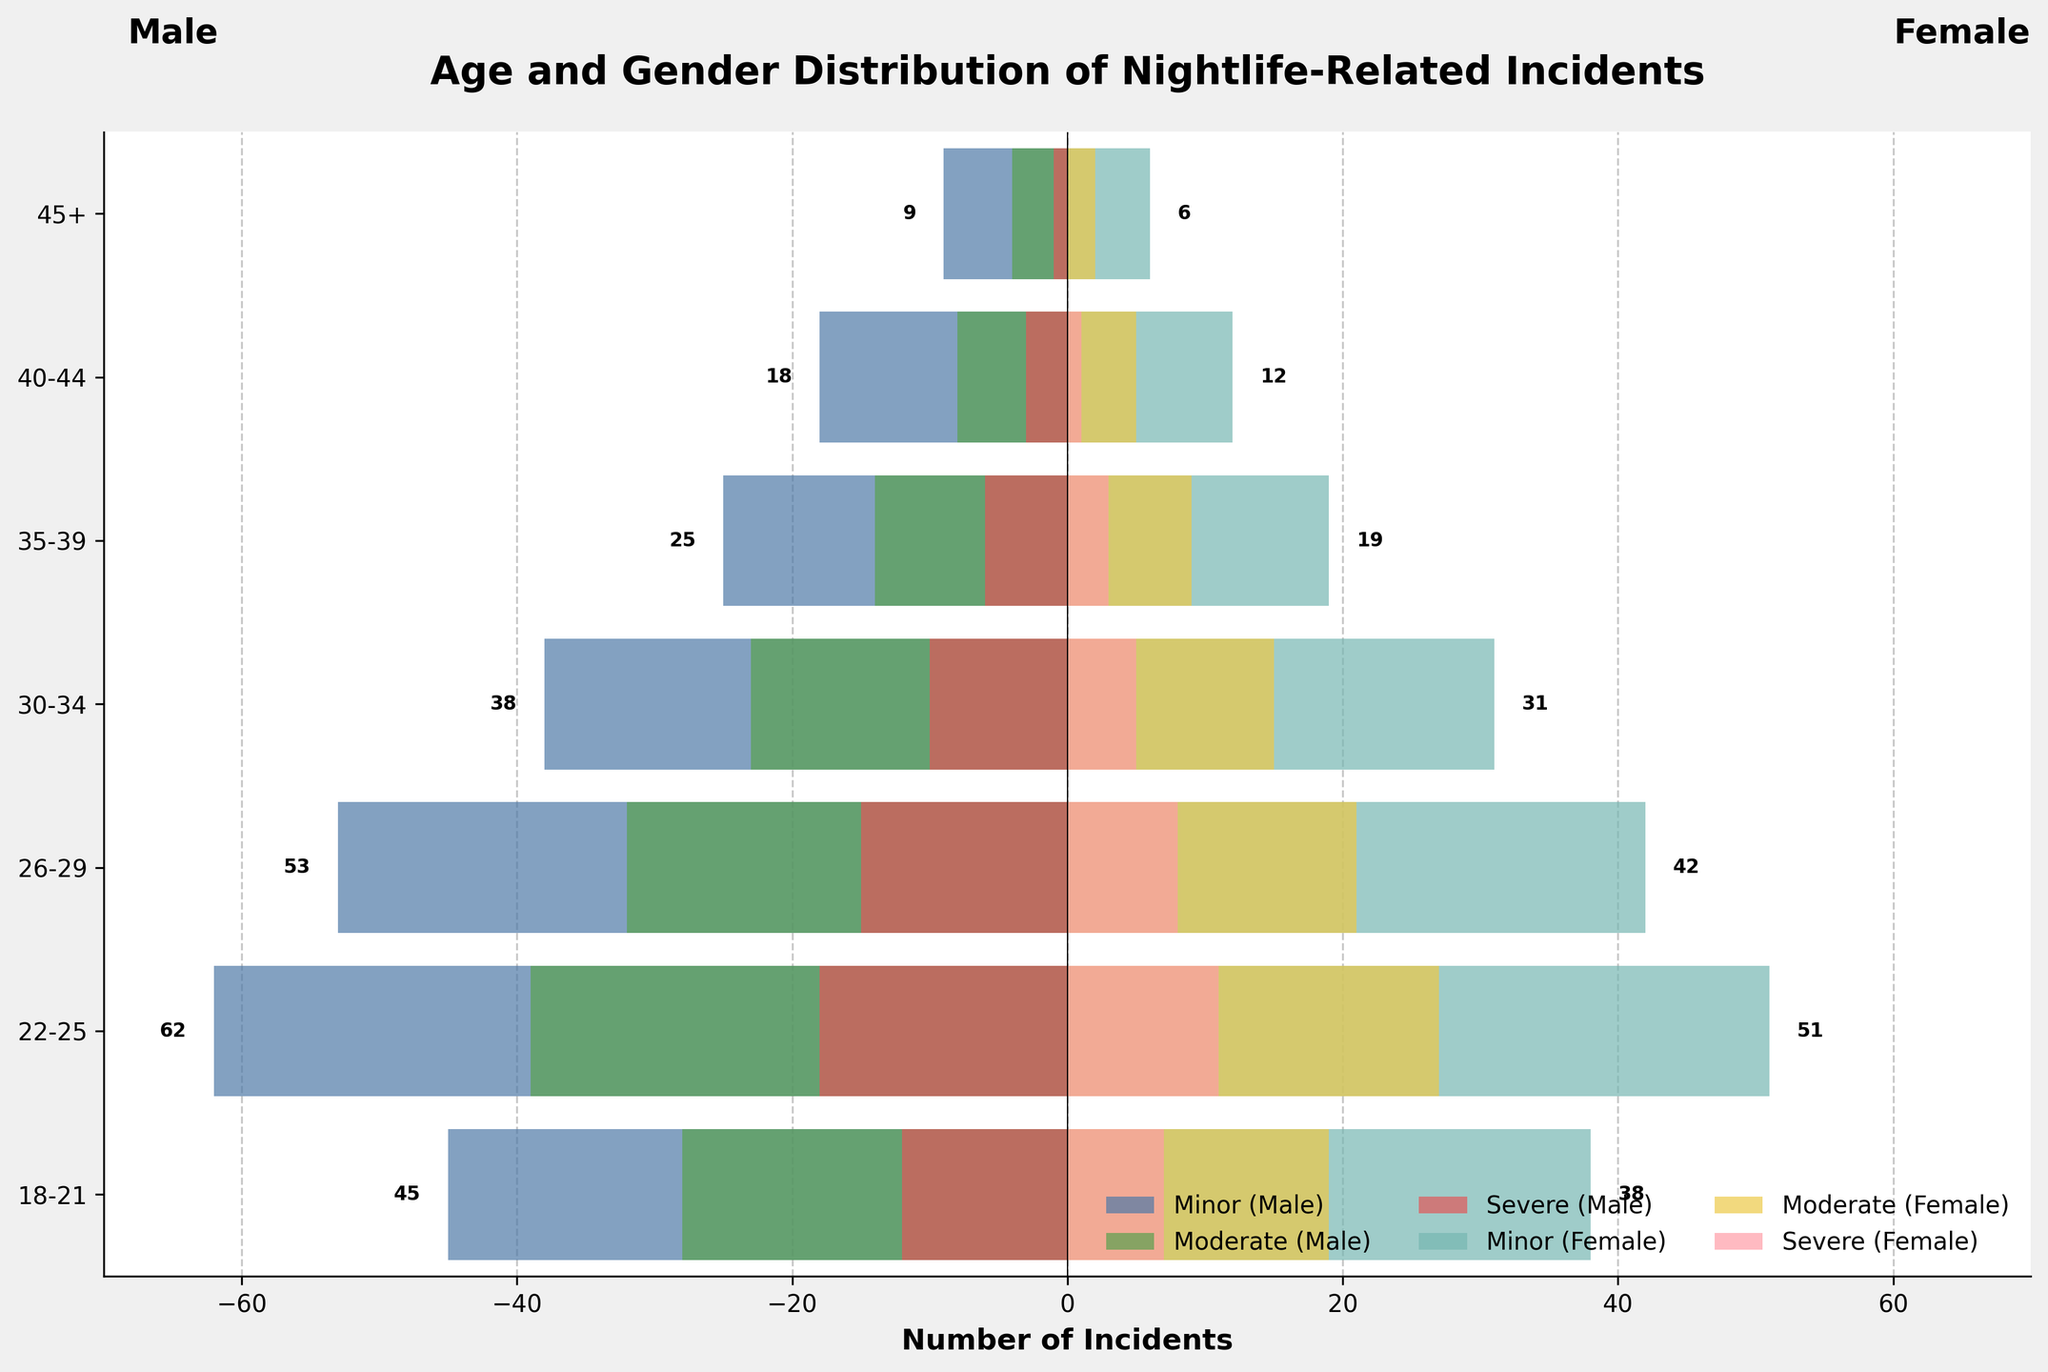what's the title of the plot? The title is bold and placed at the top center of the plot. It reads "Age and Gender Distribution of Nightlife-Related Incidents".
Answer: Age and Gender Distribution of Nightlife-Related Incidents Which age group has the highest number of minor incidents involving males? Look at the horizontal bars on the left side under the "Minor (Male)" category, the longest bar corresponds to the 22-25 age group.
Answer: 22-25 How many moderate incidents involve females in the 30-34 age group? Identify the horizontal bar corresponding to females in the 30-34 age group and read the value marked.
Answer: 15 Which age group has the least number of severe incidents involving males? Look at the horizontal bars representing "Severe (Male)" category and find the one with the smallest length, located in the 45+ age group.
Answer: 45+ Compare the number of male incidents between the age groups 22-25 and 26-29 for all severity levels. Which group has more incidents? Sum up the total number of incidents for each severity level for both age groups. For 22-25: (62+39+18=119). For 26-29: (53+32+15=100). The 22-25 age group has more incidents.
Answer: 22-25 What's the total number of incidents for females in the age group 18-21? Add up the values of all severity levels for females in the 18-21 age group: 38 (minor) + 19 (moderate) + 7 (severe) = 64.
Answer: 64 Which gender has more incidents in the 35-39 age group across all severity levels? Add up the incidents for each gender separately for the 35-39 age group. For males: (25+14+6=45). For females: (19+9+3=31). Males have more incidents.
Answer: Male How does the number of severe incidents compare between males and females in the 40-44 age group? Compare the horizontal bar lengths for the "Severe" category within the 40-44 age group. Males have more severe incidents than females (3 vs 1).
Answer: Males 